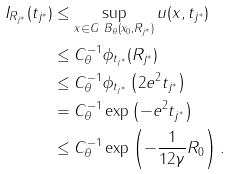Convert formula to latex. <formula><loc_0><loc_0><loc_500><loc_500>I _ { R _ { j ^ { * } } } ( t _ { j ^ { * } } ) & \leq \sup _ { x \in G \ B _ { \theta } ( x _ { 0 } , R _ { j ^ { * } } ) } u ( x , t _ { j ^ { * } } ) \\ & \leq C _ { \theta } ^ { - 1 } \phi _ { t _ { j ^ { * } } } ( R _ { j ^ { * } } ) \\ & \leq C _ { \theta } ^ { - 1 } \phi _ { t _ { j ^ { * } } } \left ( 2 e ^ { 2 } t _ { j ^ { * } } \right ) \\ & = C _ { \theta } ^ { - 1 } \exp \left ( - e ^ { 2 } t _ { j ^ { * } } \right ) \\ & \leq C _ { \theta } ^ { - 1 } \exp \left ( - \frac { 1 } { 1 2 \gamma } R _ { 0 } \right ) .</formula> 